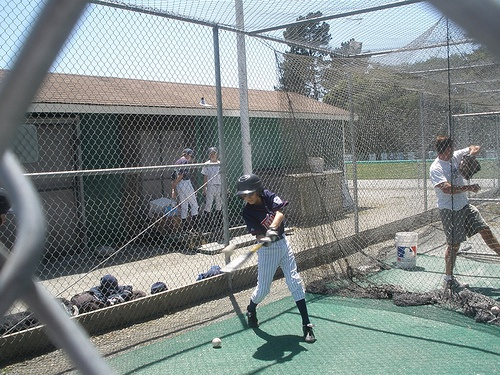Describe the objects in this image and their specific colors. I can see people in lightblue, black, gray, and darkgray tones, people in lightblue, gray, darkgray, black, and lightgray tones, people in lightblue, gray, darkgray, and black tones, people in lightblue, darkgray, gray, and black tones, and baseball glove in lightblue, gray, black, and darkgray tones in this image. 